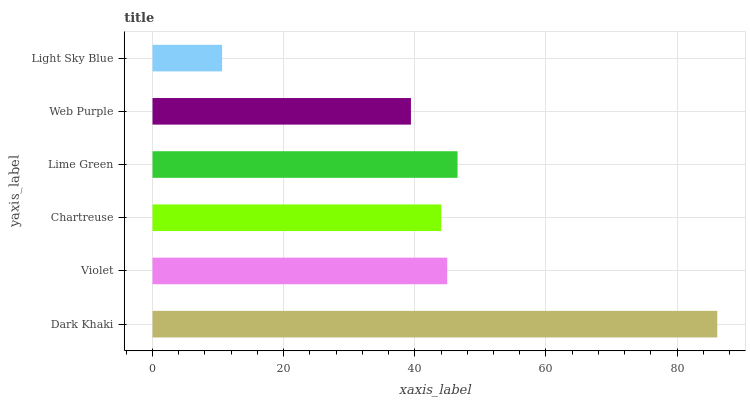Is Light Sky Blue the minimum?
Answer yes or no. Yes. Is Dark Khaki the maximum?
Answer yes or no. Yes. Is Violet the minimum?
Answer yes or no. No. Is Violet the maximum?
Answer yes or no. No. Is Dark Khaki greater than Violet?
Answer yes or no. Yes. Is Violet less than Dark Khaki?
Answer yes or no. Yes. Is Violet greater than Dark Khaki?
Answer yes or no. No. Is Dark Khaki less than Violet?
Answer yes or no. No. Is Violet the high median?
Answer yes or no. Yes. Is Chartreuse the low median?
Answer yes or no. Yes. Is Light Sky Blue the high median?
Answer yes or no. No. Is Violet the low median?
Answer yes or no. No. 